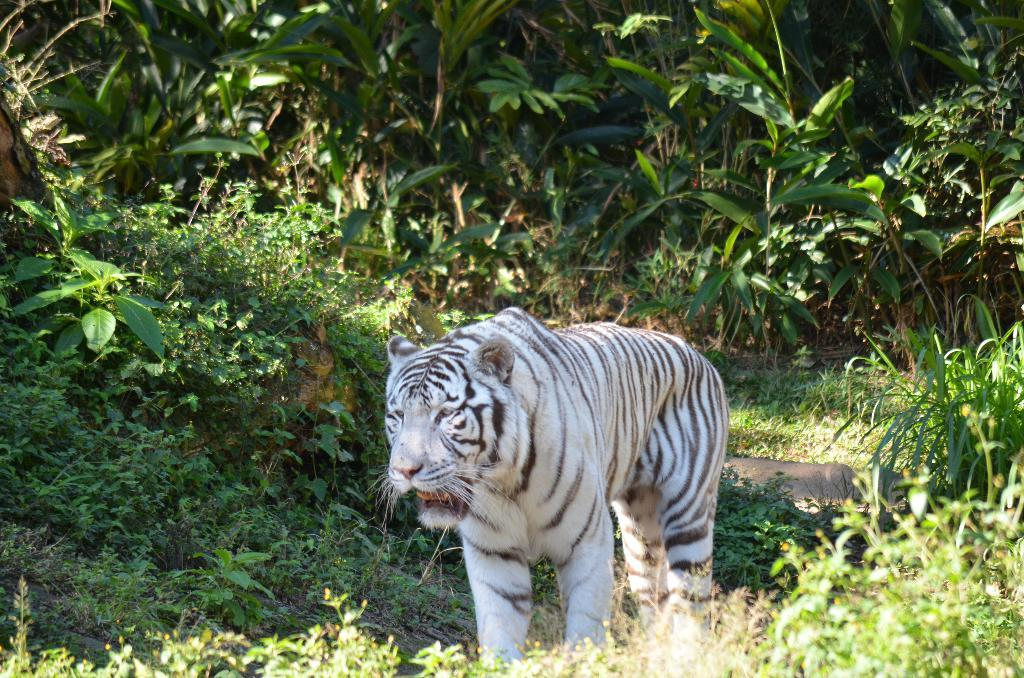What type of animal is in the image? There is a white tiger in the image. Where is the white tiger located? The white tiger is on the ground. What can be seen in the background of the image? There are many plants with leaves in the image. What park is the white tiger visiting in the image? There is no park mentioned or visible in the image; it only features a white tiger on the ground and plants with leaves in the background. 